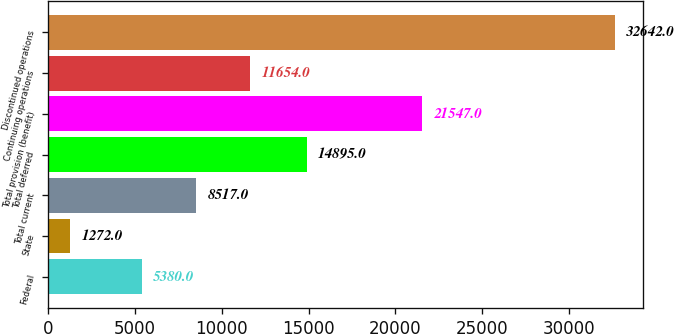<chart> <loc_0><loc_0><loc_500><loc_500><bar_chart><fcel>Federal<fcel>State<fcel>Total current<fcel>Total deferred<fcel>Total provision (benefit)<fcel>Continuing operations<fcel>Discontinued operations<nl><fcel>5380<fcel>1272<fcel>8517<fcel>14895<fcel>21547<fcel>11654<fcel>32642<nl></chart> 